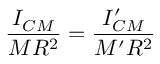Convert formula to latex. <formula><loc_0><loc_0><loc_500><loc_500>\frac { I _ { C M } } { M R ^ { 2 } } = \frac { I _ { C M } ^ { \prime } } { M ^ { \prime } R ^ { 2 } }</formula> 